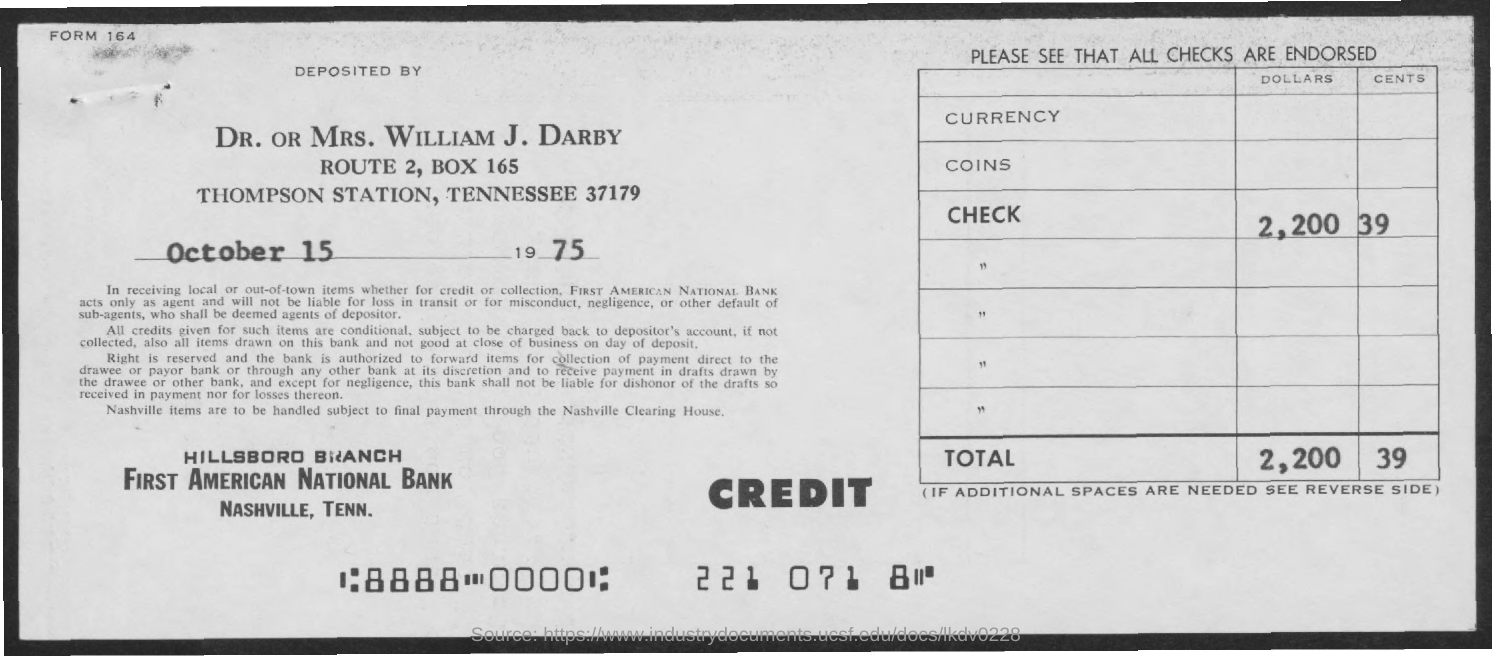What is form number mentioned at top left corner?
Your answer should be very brief. 164. Which bank is this deposit made into?
Your response must be concise. First American National Bank. How many dollars are credited?
Your answer should be compact. 2,200. How many cents are credited?
Your answer should be compact. 39. 